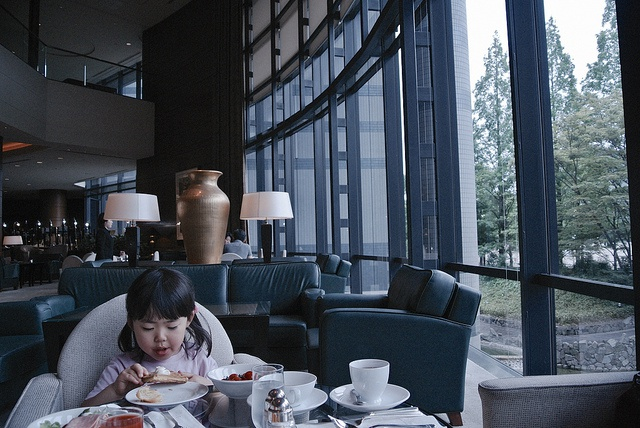Describe the objects in this image and their specific colors. I can see couch in black, navy, blue, and gray tones, couch in black, darkblue, and blue tones, people in black, gray, and darkgray tones, chair in black, gray, and darkgray tones, and chair in black, gray, and darkgray tones in this image. 